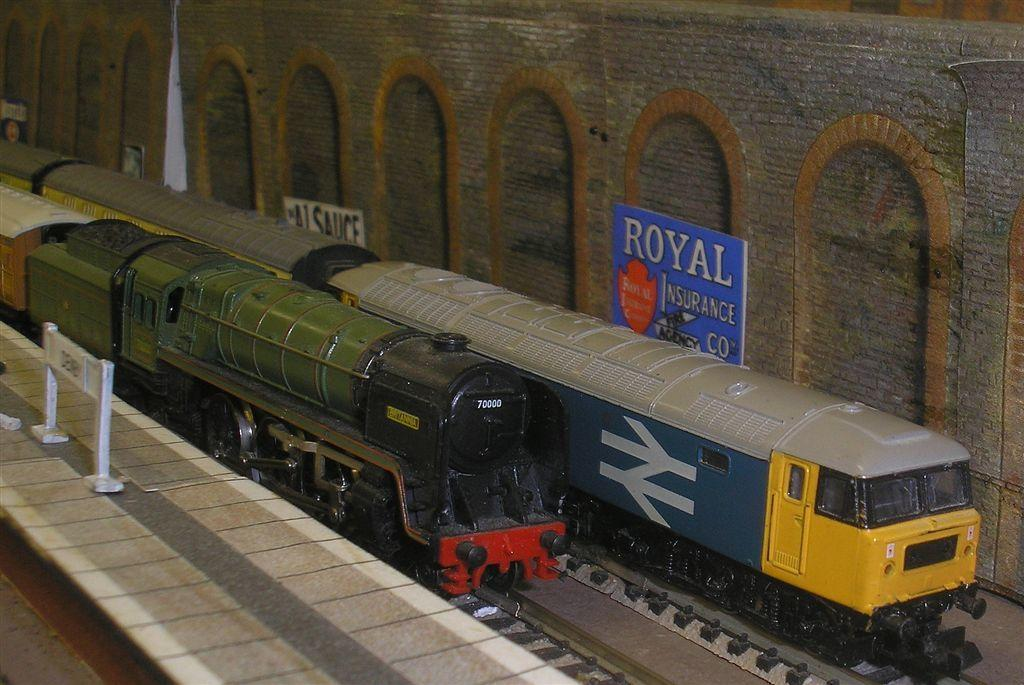What is the main subject of the image? The main subject of the image is trains on a railway track. What can be seen on the right side of the image? There is a barricade on the right side of the image. What type of landscape is visible in the image? There are fields (acres) visible in the image. What is present on the left side of the image? There is a board on the wall on the left side of the image. What type of plants can be seen growing on the trains in the image? There are no plants growing on the trains in the image. How many hydrants are visible in the image? There are no hydrants present in the image. 